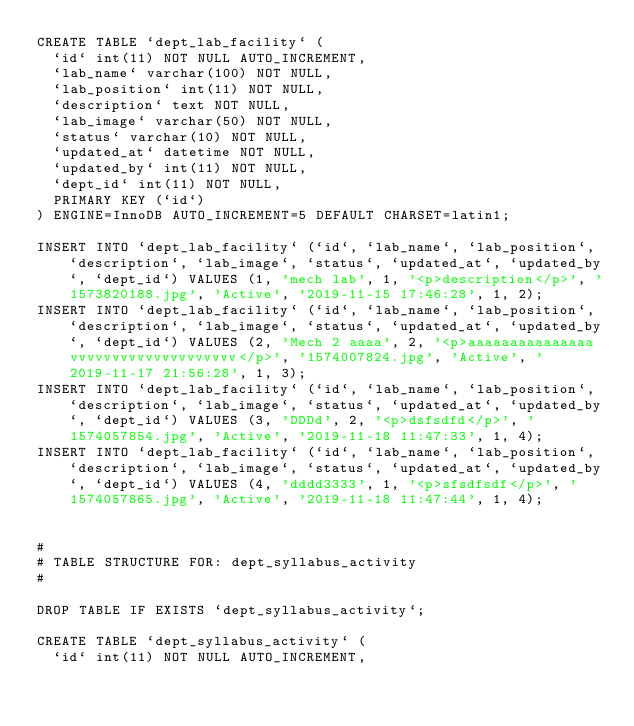Convert code to text. <code><loc_0><loc_0><loc_500><loc_500><_SQL_>CREATE TABLE `dept_lab_facility` (
  `id` int(11) NOT NULL AUTO_INCREMENT,
  `lab_name` varchar(100) NOT NULL,
  `lab_position` int(11) NOT NULL,
  `description` text NOT NULL,
  `lab_image` varchar(50) NOT NULL,
  `status` varchar(10) NOT NULL,
  `updated_at` datetime NOT NULL,
  `updated_by` int(11) NOT NULL,
  `dept_id` int(11) NOT NULL,
  PRIMARY KEY (`id`)
) ENGINE=InnoDB AUTO_INCREMENT=5 DEFAULT CHARSET=latin1;

INSERT INTO `dept_lab_facility` (`id`, `lab_name`, `lab_position`, `description`, `lab_image`, `status`, `updated_at`, `updated_by`, `dept_id`) VALUES (1, 'mech lab', 1, '<p>description</p>', '1573820188.jpg', 'Active', '2019-11-15 17:46:28', 1, 2);
INSERT INTO `dept_lab_facility` (`id`, `lab_name`, `lab_position`, `description`, `lab_image`, `status`, `updated_at`, `updated_by`, `dept_id`) VALUES (2, 'Mech 2 aaaa', 2, '<p>aaaaaaaaaaaaaaa vvvvvvvvvvvvvvvvvvvv</p>', '1574007824.jpg', 'Active', '2019-11-17 21:56:28', 1, 3);
INSERT INTO `dept_lab_facility` (`id`, `lab_name`, `lab_position`, `description`, `lab_image`, `status`, `updated_at`, `updated_by`, `dept_id`) VALUES (3, 'DDDd', 2, '<p>dsfsdfd</p>', '1574057854.jpg', 'Active', '2019-11-18 11:47:33', 1, 4);
INSERT INTO `dept_lab_facility` (`id`, `lab_name`, `lab_position`, `description`, `lab_image`, `status`, `updated_at`, `updated_by`, `dept_id`) VALUES (4, 'dddd3333', 1, '<p>sfsdfsdf</p>', '1574057865.jpg', 'Active', '2019-11-18 11:47:44', 1, 4);


#
# TABLE STRUCTURE FOR: dept_syllabus_activity
#

DROP TABLE IF EXISTS `dept_syllabus_activity`;

CREATE TABLE `dept_syllabus_activity` (
  `id` int(11) NOT NULL AUTO_INCREMENT,</code> 